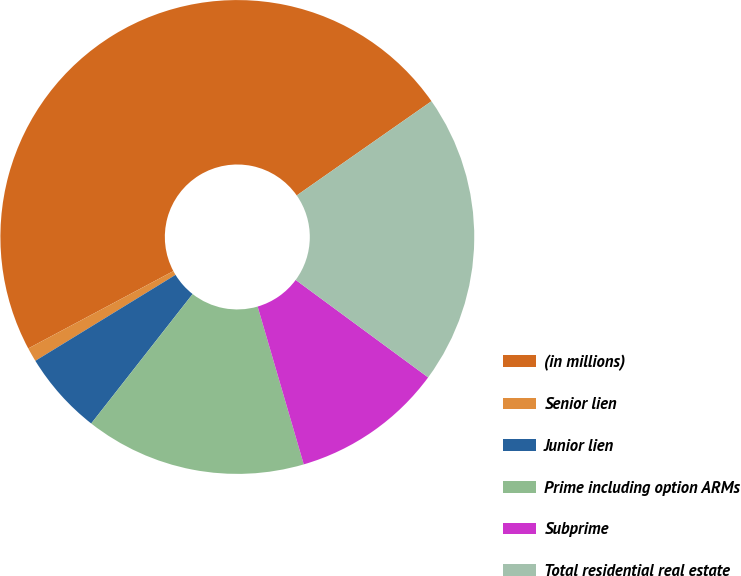<chart> <loc_0><loc_0><loc_500><loc_500><pie_chart><fcel>(in millions)<fcel>Senior lien<fcel>Junior lien<fcel>Prime including option ARMs<fcel>Subprime<fcel>Total residential real estate<nl><fcel>48.09%<fcel>0.96%<fcel>5.67%<fcel>15.1%<fcel>10.38%<fcel>19.81%<nl></chart> 